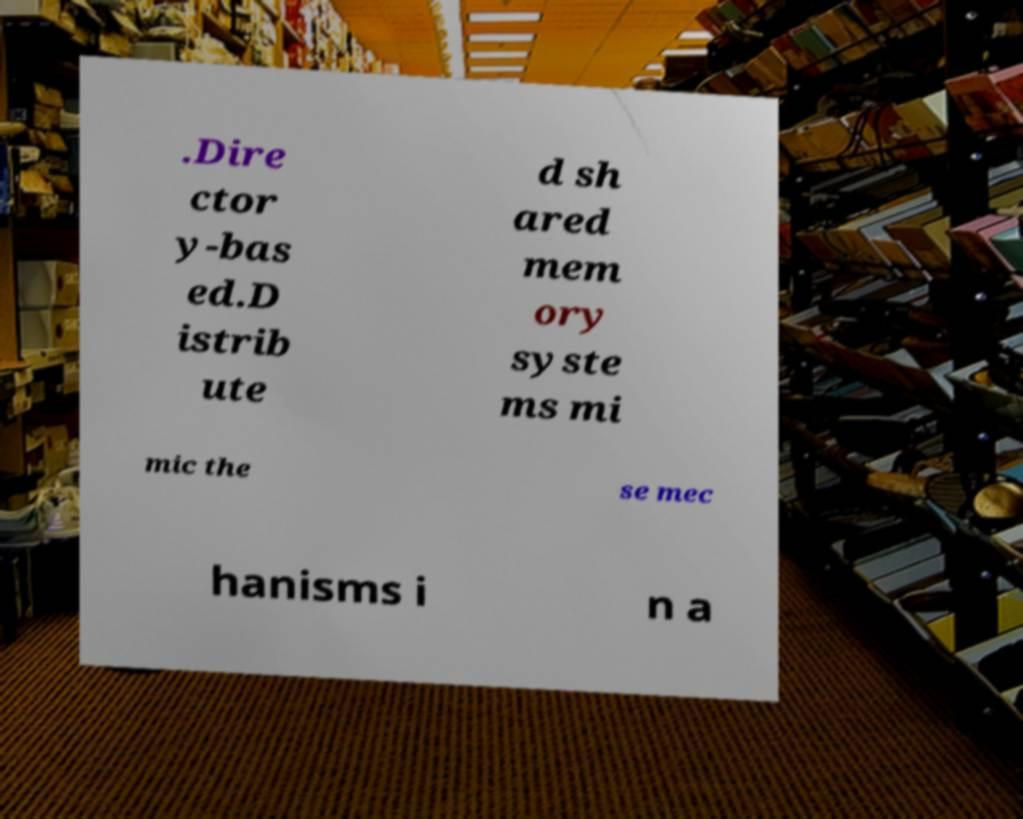Could you extract and type out the text from this image? .Dire ctor y-bas ed.D istrib ute d sh ared mem ory syste ms mi mic the se mec hanisms i n a 